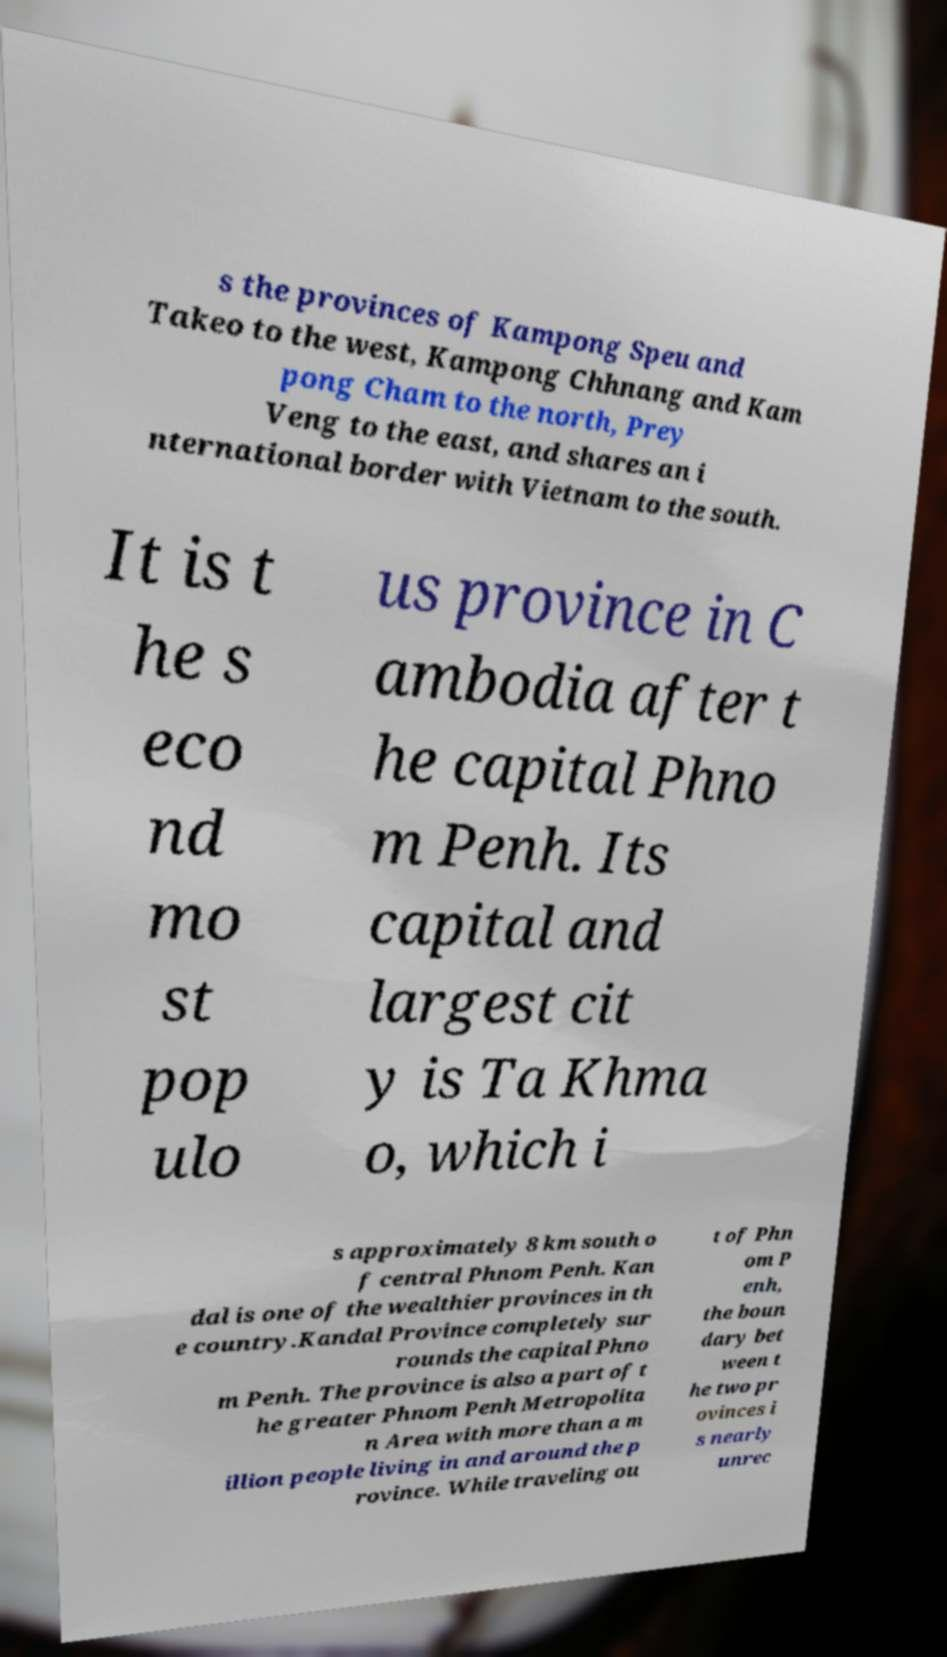Could you assist in decoding the text presented in this image and type it out clearly? s the provinces of Kampong Speu and Takeo to the west, Kampong Chhnang and Kam pong Cham to the north, Prey Veng to the east, and shares an i nternational border with Vietnam to the south. It is t he s eco nd mo st pop ulo us province in C ambodia after t he capital Phno m Penh. Its capital and largest cit y is Ta Khma o, which i s approximately 8 km south o f central Phnom Penh. Kan dal is one of the wealthier provinces in th e country.Kandal Province completely sur rounds the capital Phno m Penh. The province is also a part of t he greater Phnom Penh Metropolita n Area with more than a m illion people living in and around the p rovince. While traveling ou t of Phn om P enh, the boun dary bet ween t he two pr ovinces i s nearly unrec 